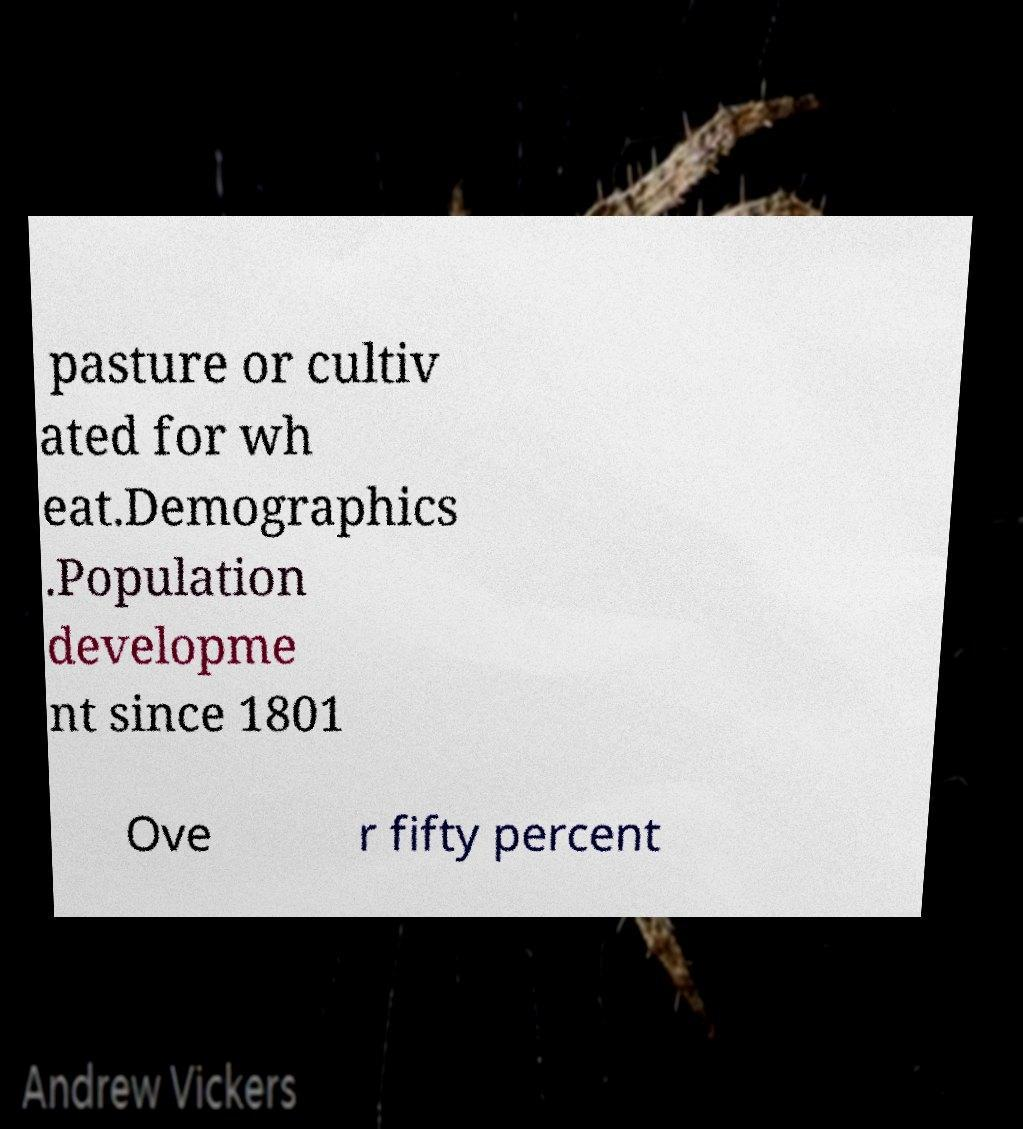Could you assist in decoding the text presented in this image and type it out clearly? pasture or cultiv ated for wh eat.Demographics .Population developme nt since 1801 Ove r fifty percent 